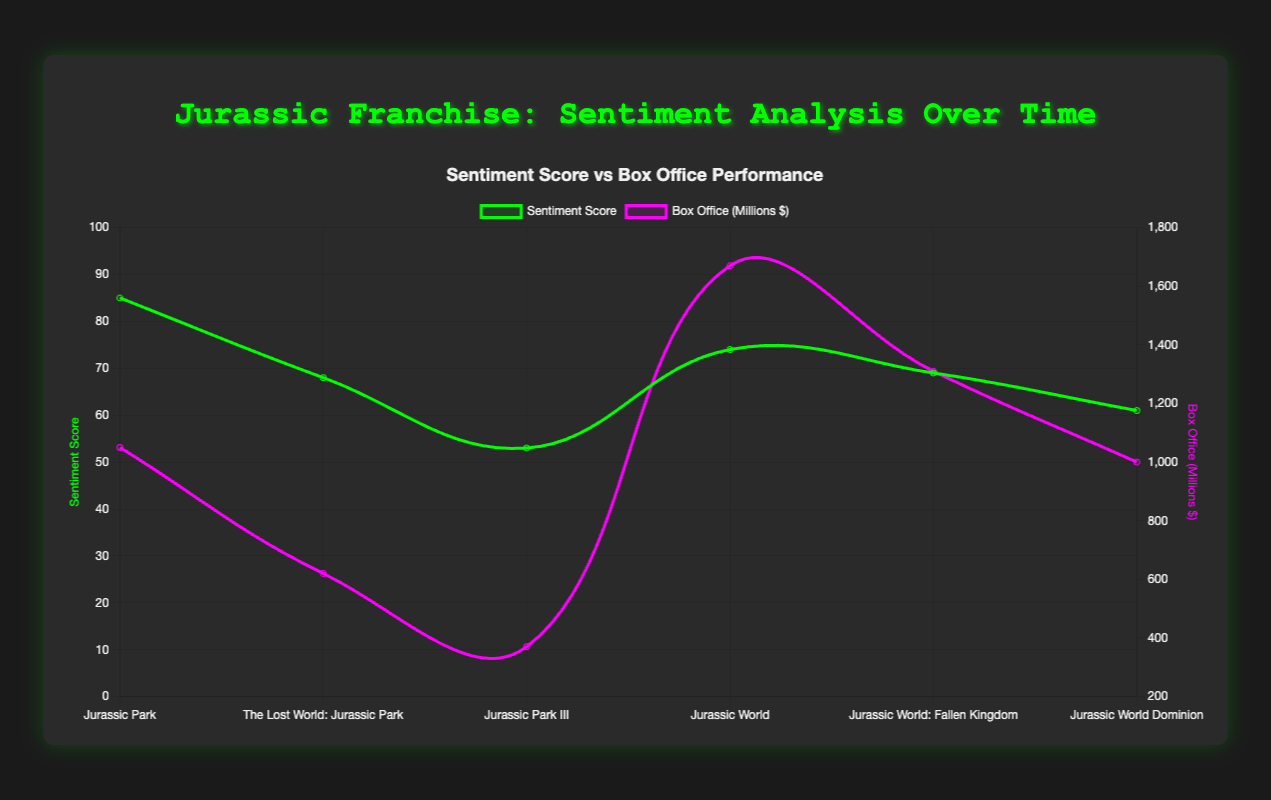What trend do you observe in the sentiment scores over the film releases? The sentiment scores start high with "Jurassic Park" at 85, then generally decrease over successive films, except for a rise in "Jurassic World" at 74, before declining again.
Answer: The sentiment scores generally decrease over time Which film had the highest sentiment score and box office performance? "Jurassic Park" had the highest sentiment score at 85, while "Jurassic World" had the highest box office performance at $1670 million.
Answer: "Jurassic Park" and "Jurassic World" How does the sentiment score of "Jurassic World Dominion" compare to "Jurassic Park"? "Jurassic World Dominion" has a sentiment score of 61, while "Jurassic Park" has 85. The sentiment score of "Jurassic World Dominion" is significantly lower than that of "Jurassic Park".
Answer: Lower What is the average sentiment score for the Jurassic World trilogy? The sentiment scores for the Jurassic World trilogy are 74, 69, and 61. The average is (74 + 69 + 61) / 3 = 68.
Answer: 68 Did any film have a higher sentiment score than "Jurassic World" but a lower box office performance? "Jurassic Park" had a higher sentiment score (85) than "Jurassic World" (74), but a lower box office performance ($1050 million compared to $1670 million).
Answer: Yes What can be deduced about the relationship between sentiment score and box office performance in the "Jurassic World" films? The sentiment scores for the "Jurassic World" films are 74, 69, and 61, while their box office performances are $1670 million, $1310 million, and $1000 million, respectively. Although sentiment scores decrease, box office performance also decreases.
Answer: Both decrease Which film had the most significant drop in sentiment score from its predecessor? "Jurassic Park III" had the most significant drop in sentiment score from "The Lost World: Jurassic Park", dropping from 68 to 53.
Answer: "Jurassic Park III" How do the sentiment scores of the original trilogy compare to the Jurassic World trilogy? The original trilogy (85, 68, 53) vs the Jurassic World trilogy (74, 69, 61). The original starts higher but declines more steeply, while the Jurassic World trilogy has a more moderate decline.
Answer: Original declines more steeply What is the median sentiment score across all films? The sentiment scores are 85, 68, 53, 74, 69, 61. Arranged in order: 53, 61, 68, 69, 74, 85. The median is (68 + 69) / 2 = 68.5.
Answer: 68.5 Comparing "Jurassic Park" and "Jurassic World Dominion", how did the sentiment scores and box office earnings change? "Jurassic Park" had an 85 sentiment score and $1050 million box office. "Jurassic World Dominion" had a 61 sentiment score and $1000 million box office. Both sentiment scores and box office earnings decreased.
Answer: Both decreased 